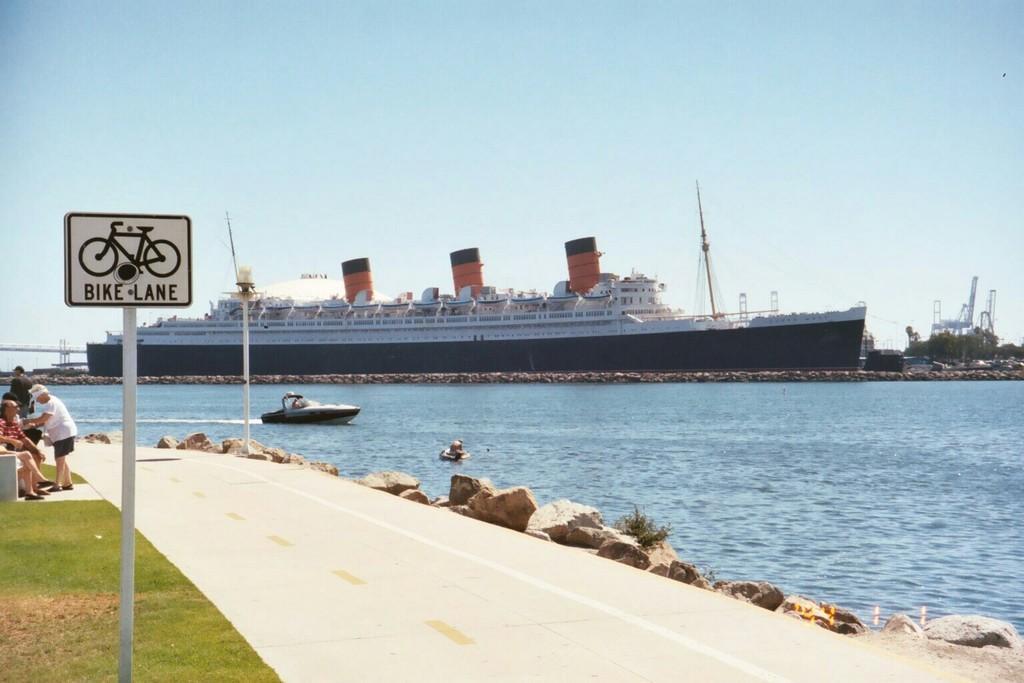Please provide a concise description of this image. In this picture we can see a pole with a sign board. Behind the pole there are some people standing and some people sitting on a bench. On the right side of the people there are rocks and boats on the water. Behind the boats there's a ship and they are looking like trees and behind the ship there is the sky. 